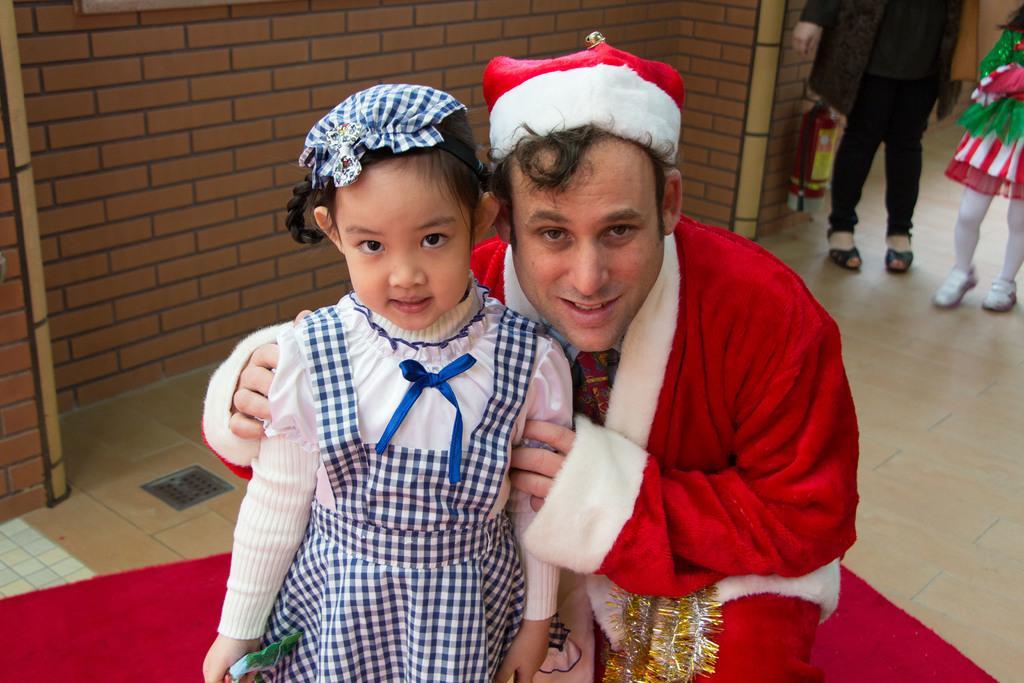Could you give a brief overview of what you see in this image? In this picture we can see a small girl wearing black and white checks top, smiling and looking into the camera. Beside we can see a man wearing Santa Claus red color dress looking in the camera. In the background we can see brick color wall. 